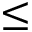Convert formula to latex. <formula><loc_0><loc_0><loc_500><loc_500>\leq</formula> 